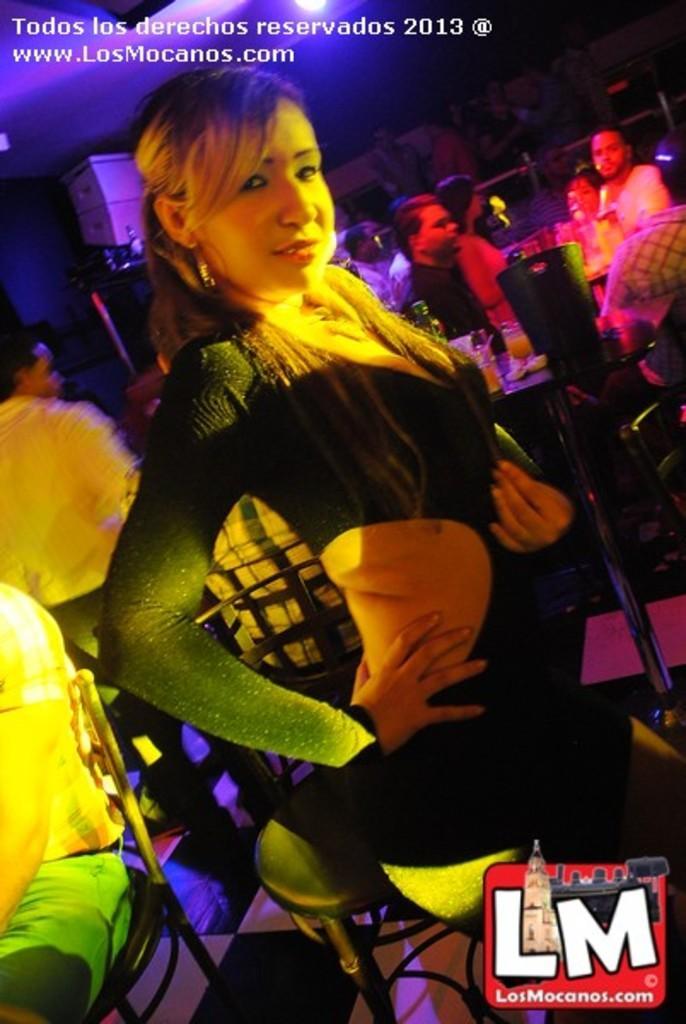Please provide a concise description of this image. The picture is taken from some website it looks like a party in a club, there are many people and there is a woman in the front posing for the photo and behind her there is a table and on the table there are some drinks and there are different types of lights focusing on the people. 